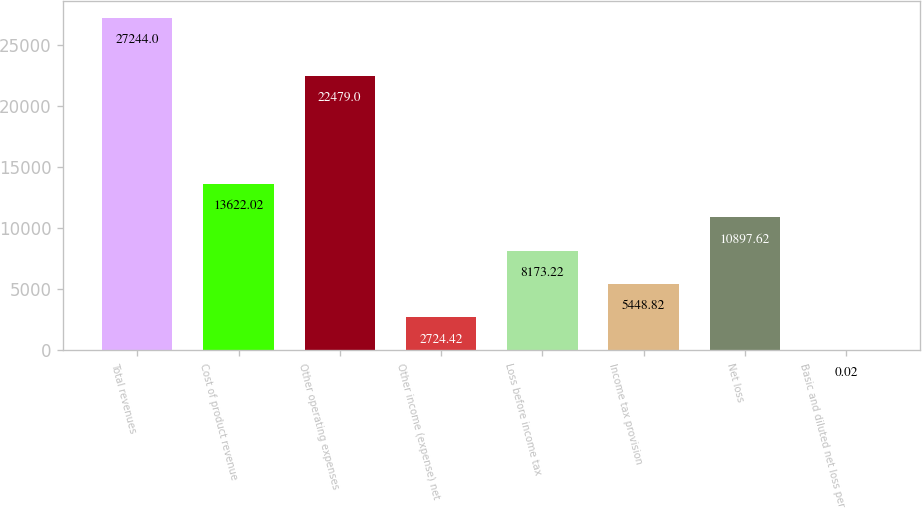<chart> <loc_0><loc_0><loc_500><loc_500><bar_chart><fcel>Total revenues<fcel>Cost of product revenue<fcel>Other operating expenses<fcel>Other income (expense) net<fcel>Loss before income tax<fcel>Income tax provision<fcel>Net loss<fcel>Basic and diluted net loss per<nl><fcel>27244<fcel>13622<fcel>22479<fcel>2724.42<fcel>8173.22<fcel>5448.82<fcel>10897.6<fcel>0.02<nl></chart> 